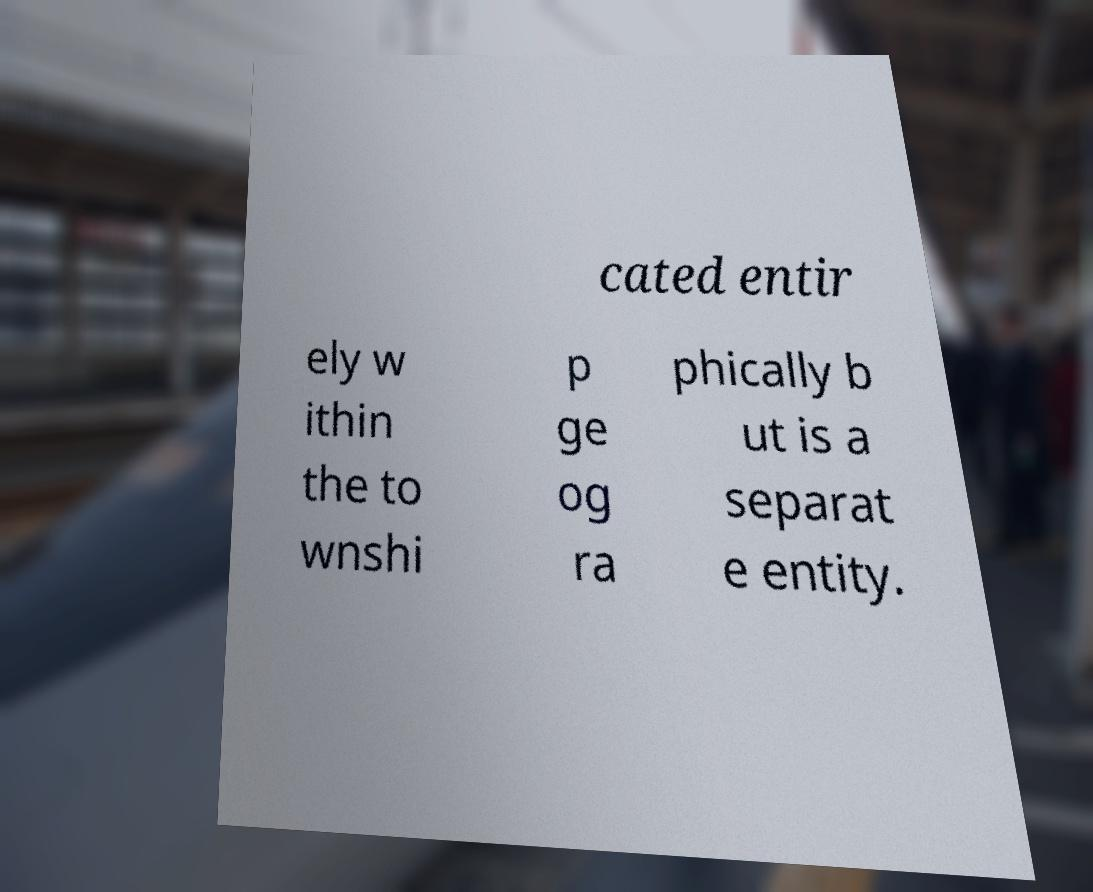For documentation purposes, I need the text within this image transcribed. Could you provide that? cated entir ely w ithin the to wnshi p ge og ra phically b ut is a separat e entity. 